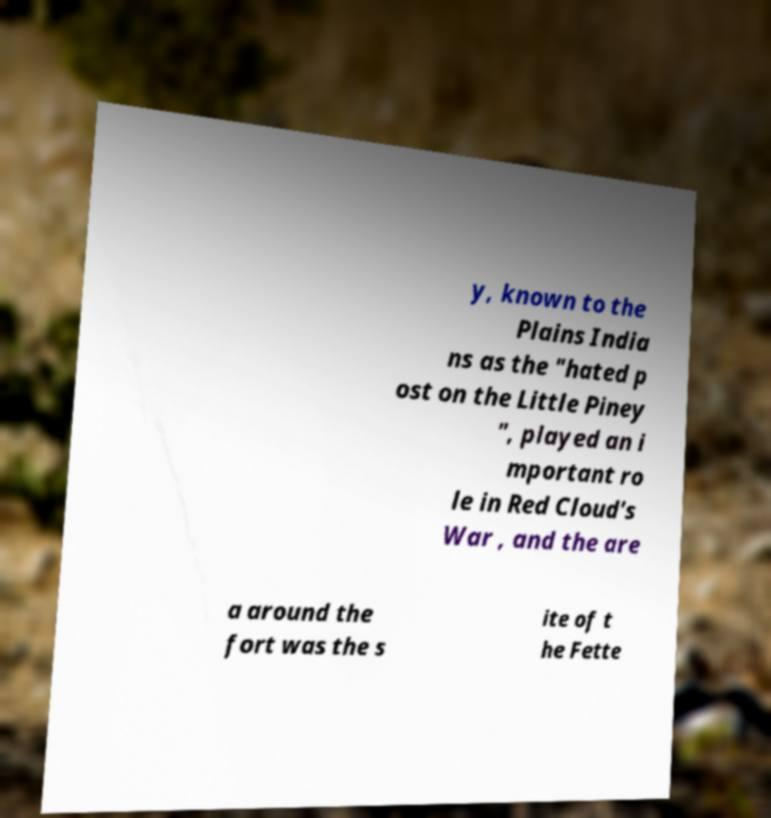Can you accurately transcribe the text from the provided image for me? y, known to the Plains India ns as the "hated p ost on the Little Piney ", played an i mportant ro le in Red Cloud's War , and the are a around the fort was the s ite of t he Fette 